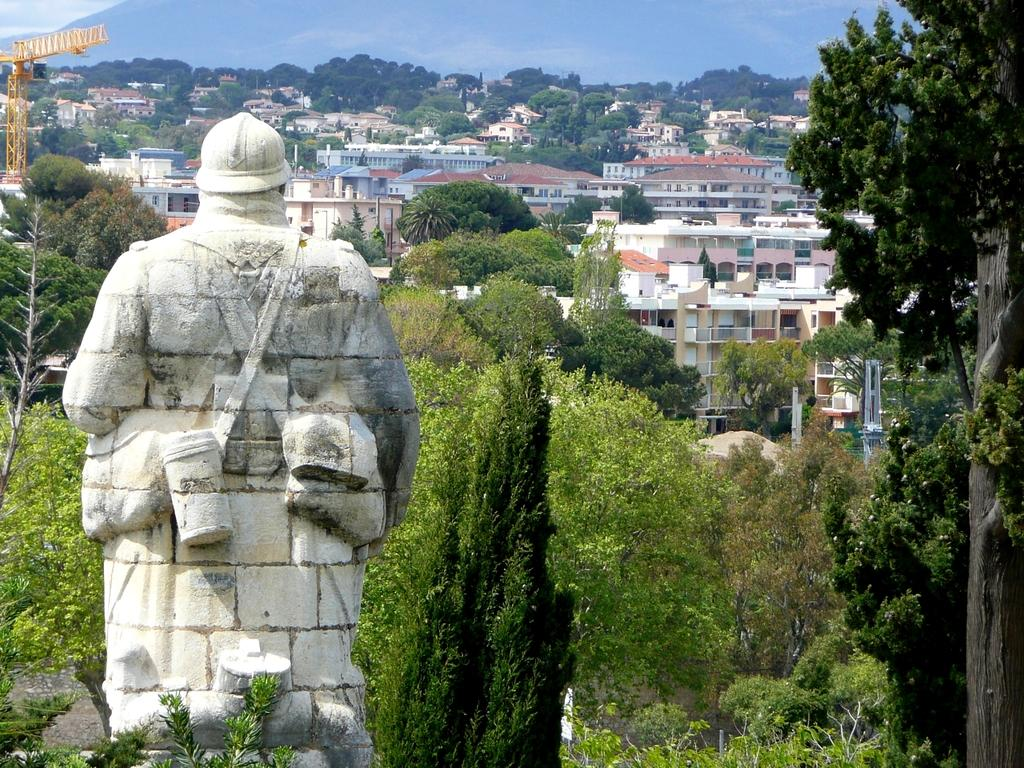What is located on the left side of the image? There is a statue on the left side of the image. What can be seen in the background of the image? There are trees, rocks, buildings, towers, poles, and a hill in the background of the image. What type of cake is being served on the ground in the image? There is no cake or ground present in the image; it features a statue and various elements in the background. 